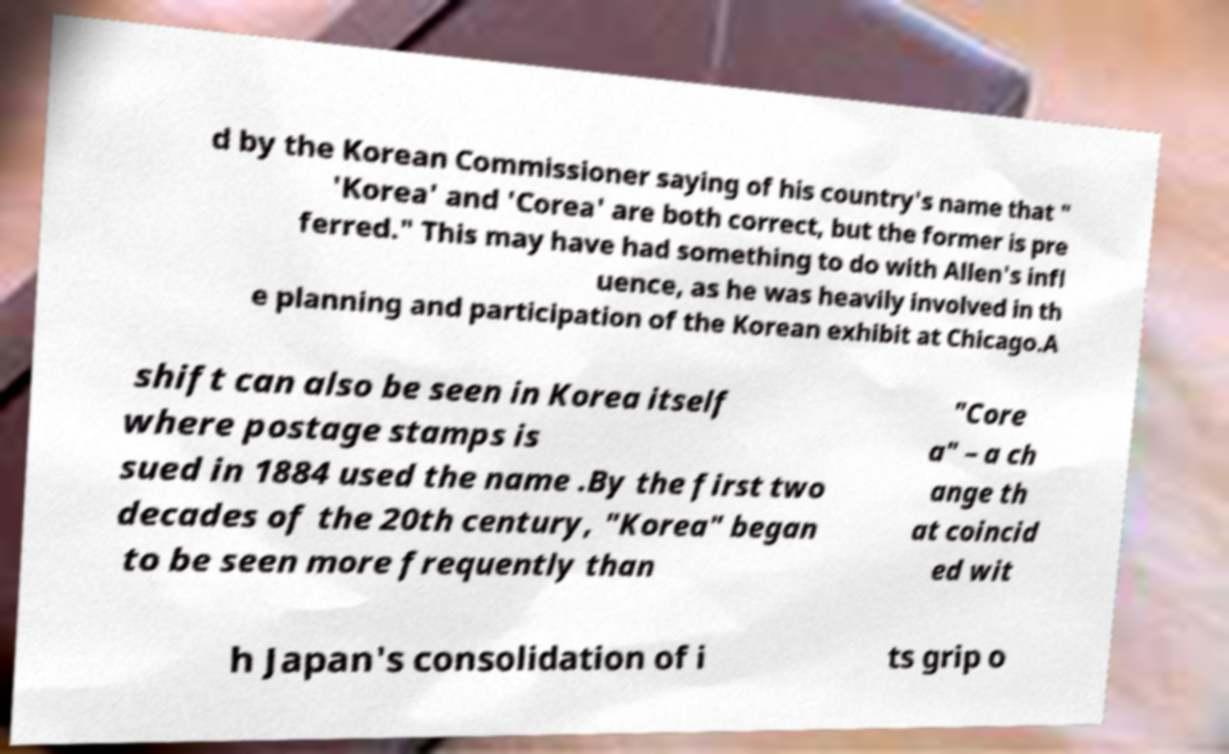I need the written content from this picture converted into text. Can you do that? d by the Korean Commissioner saying of his country's name that " 'Korea' and 'Corea' are both correct, but the former is pre ferred." This may have had something to do with Allen's infl uence, as he was heavily involved in th e planning and participation of the Korean exhibit at Chicago.A shift can also be seen in Korea itself where postage stamps is sued in 1884 used the name .By the first two decades of the 20th century, "Korea" began to be seen more frequently than "Core a" – a ch ange th at coincid ed wit h Japan's consolidation of i ts grip o 